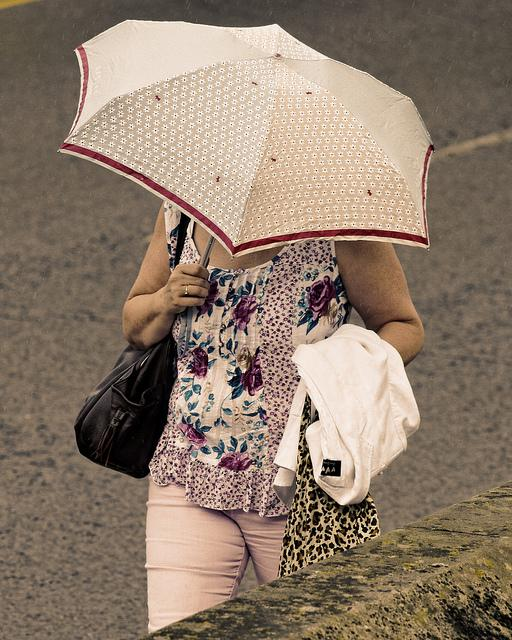Why is she holding an umbrella in dry weather? block sun 